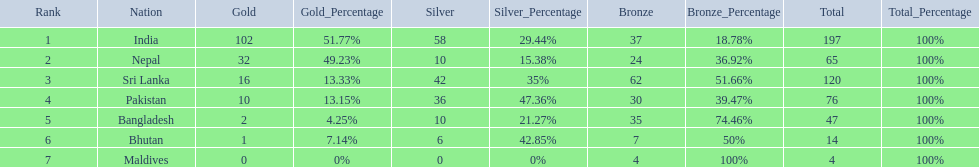What are all the countries listed in the table? India, Nepal, Sri Lanka, Pakistan, Bangladesh, Bhutan, Maldives. Which of these is not india? Nepal, Sri Lanka, Pakistan, Bangladesh, Bhutan, Maldives. Of these, which is first? Nepal. 